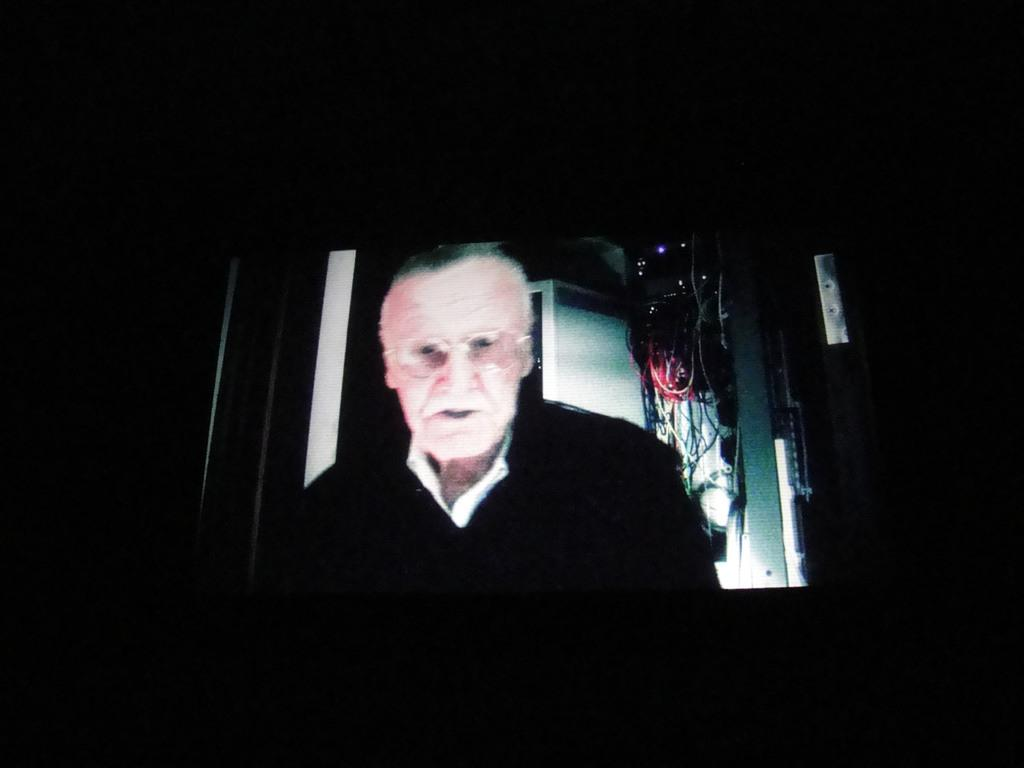What is the main object in the center of the image? There is a screen in the center of the image. What can be seen on the screen? A person is present on the screen. Are there any visible connections to the screen? Yes, there are cables visible on the screen. How would you describe the overall lighting in the image? The background of the image is dark. What month is it in the image? The month cannot be determined from the image, as it does not contain any information about the time or date. 